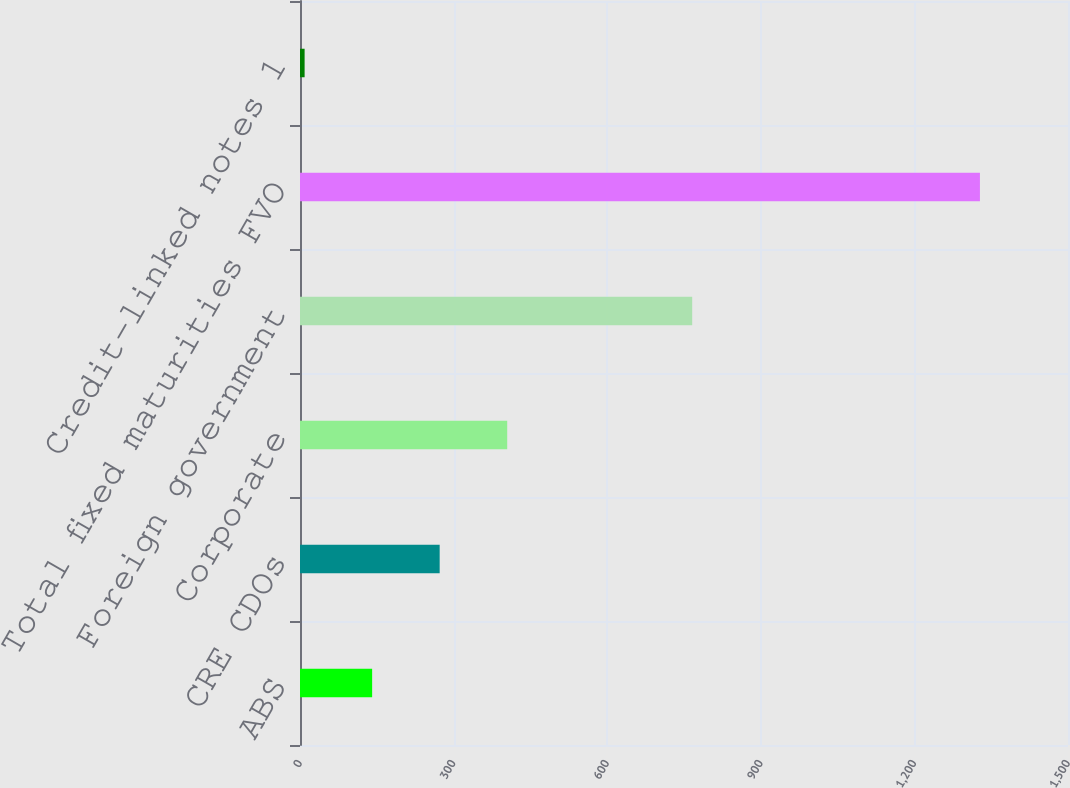<chart> <loc_0><loc_0><loc_500><loc_500><bar_chart><fcel>ABS<fcel>CRE CDOs<fcel>Corporate<fcel>Foreign government<fcel>Total fixed maturities FVO<fcel>Credit-linked notes 1<nl><fcel>140.9<fcel>272.8<fcel>404.7<fcel>766<fcel>1328<fcel>9<nl></chart> 